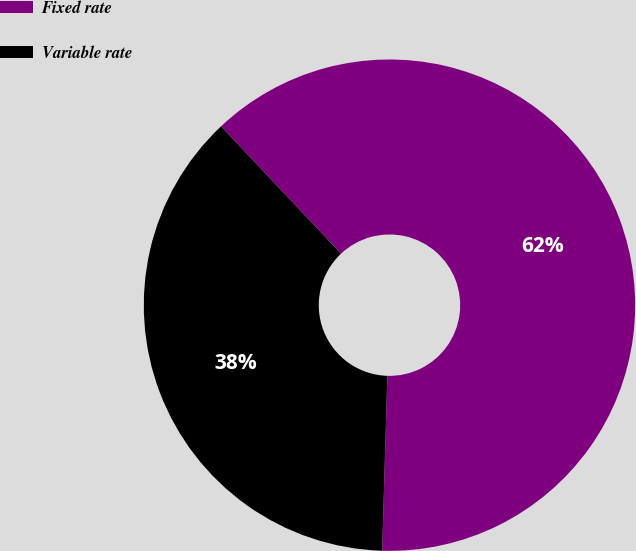<chart> <loc_0><loc_0><loc_500><loc_500><pie_chart><fcel>Fixed rate<fcel>Variable rate<nl><fcel>62.5%<fcel>37.5%<nl></chart> 